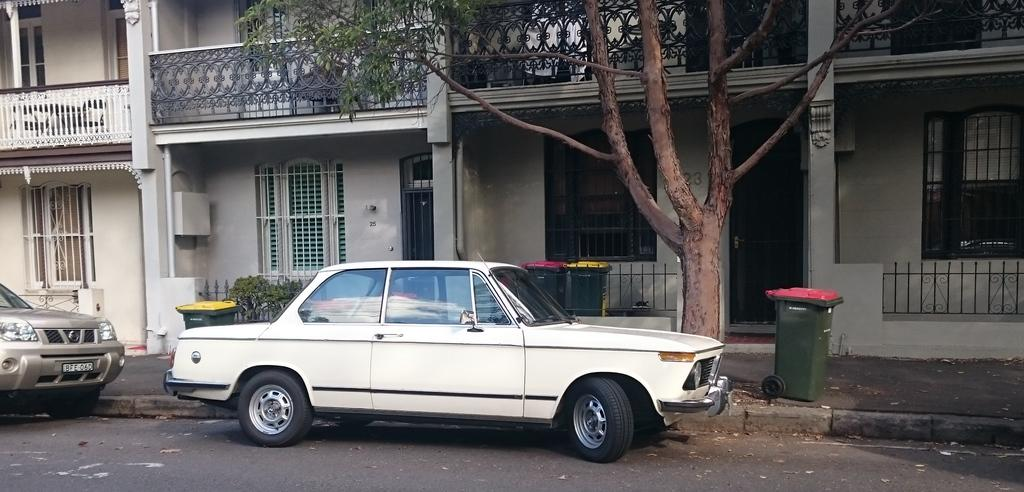What can be seen on the road in the image? There are vehicles on the road in the image. What is located on the footpath in the image? There are dust bins on the footpath in the image. What type of vegetation is present in the image? There is a tree and plants in the image. What can be seen in the background of the image? There are buildings with windows and railings in the background of the image. What else is visible in the background of the image? There are some objects visible in the background of the image. How much does the laborer charge for their services in the image? There is no laborer present in the image, so it is not possible to determine their charges. How many dimes are visible on the vehicles in the image? There are no dimes visible on the vehicles in the image. 